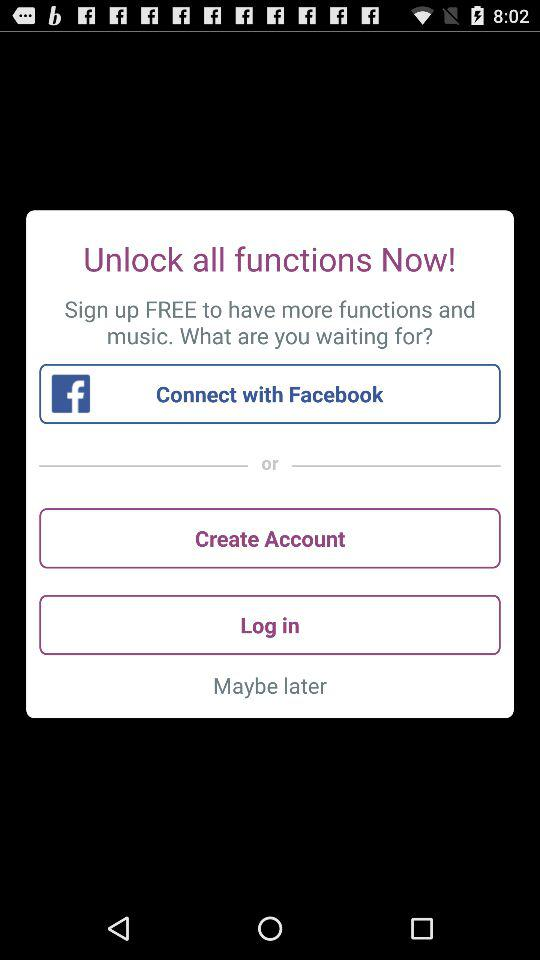What are the different options available for logging in? The available option for logging in is "Facebook". 